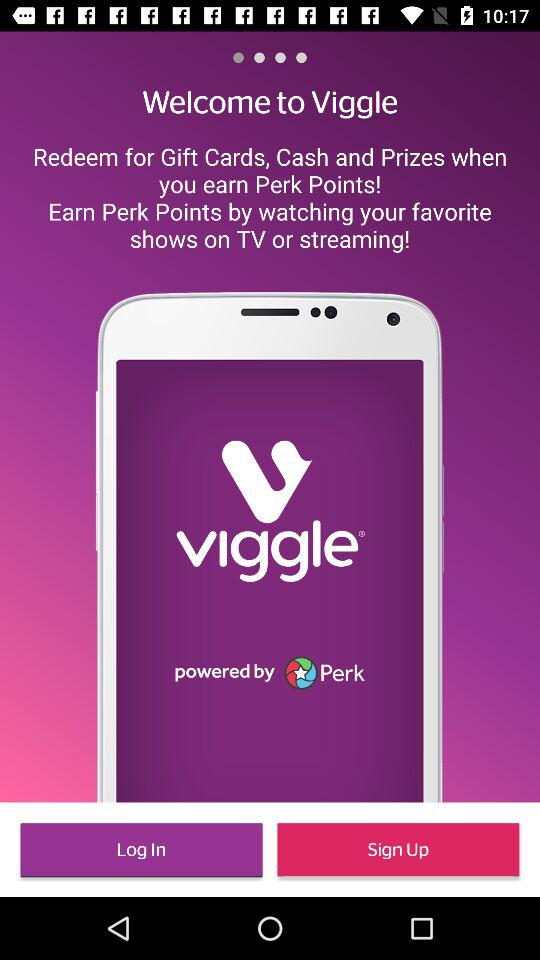What can you redeem when you earn Perk Points? You can redeem your perk points for gift cards, cash and prizes. 